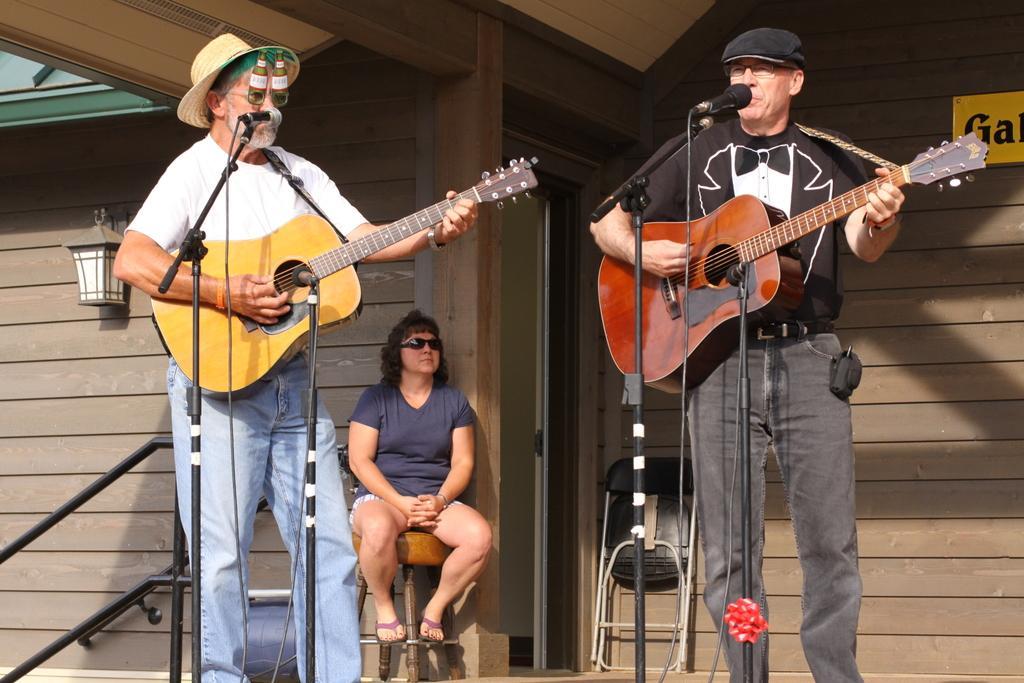Could you give a brief overview of what you see in this image? In this image their are two persons holding the guitar and singing the song in front of the mike and one woman is sitting on the chair behind the person one house is there and the background is sunny. 